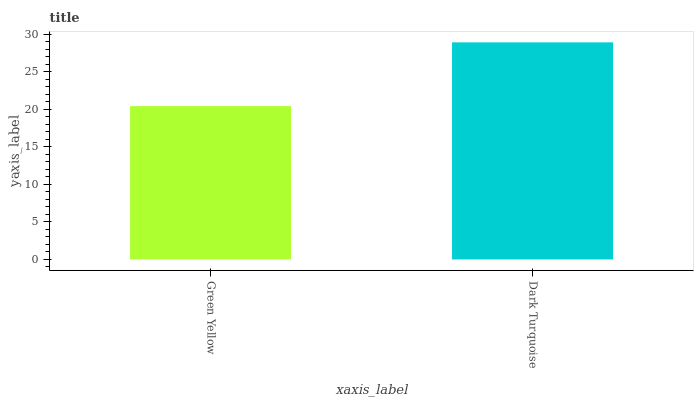Is Green Yellow the minimum?
Answer yes or no. Yes. Is Dark Turquoise the maximum?
Answer yes or no. Yes. Is Dark Turquoise the minimum?
Answer yes or no. No. Is Dark Turquoise greater than Green Yellow?
Answer yes or no. Yes. Is Green Yellow less than Dark Turquoise?
Answer yes or no. Yes. Is Green Yellow greater than Dark Turquoise?
Answer yes or no. No. Is Dark Turquoise less than Green Yellow?
Answer yes or no. No. Is Dark Turquoise the high median?
Answer yes or no. Yes. Is Green Yellow the low median?
Answer yes or no. Yes. Is Green Yellow the high median?
Answer yes or no. No. Is Dark Turquoise the low median?
Answer yes or no. No. 